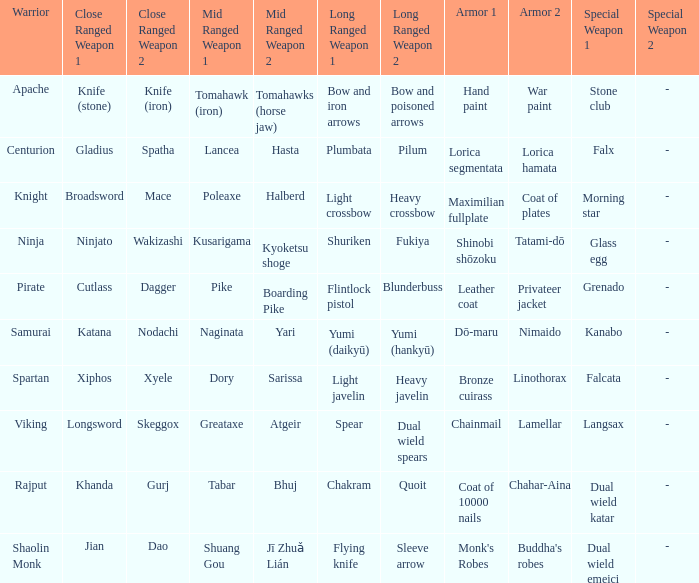If the near-range weapons are the knife (stone) and knife (iron), what are the far-range weapons? Bow and iron arrows, Bow and poisoned arrows. 